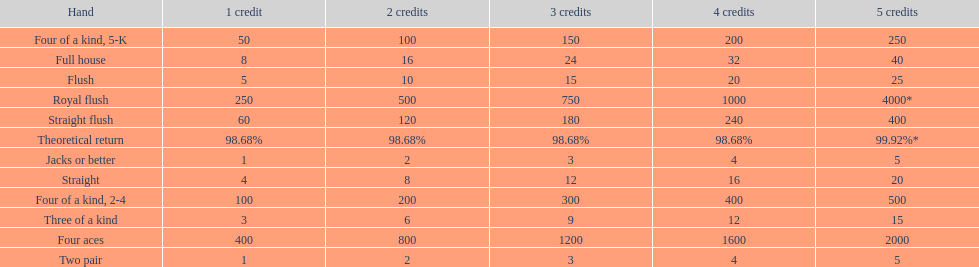What is the difference of payout on 3 credits, between a straight flush and royal flush? 570. 